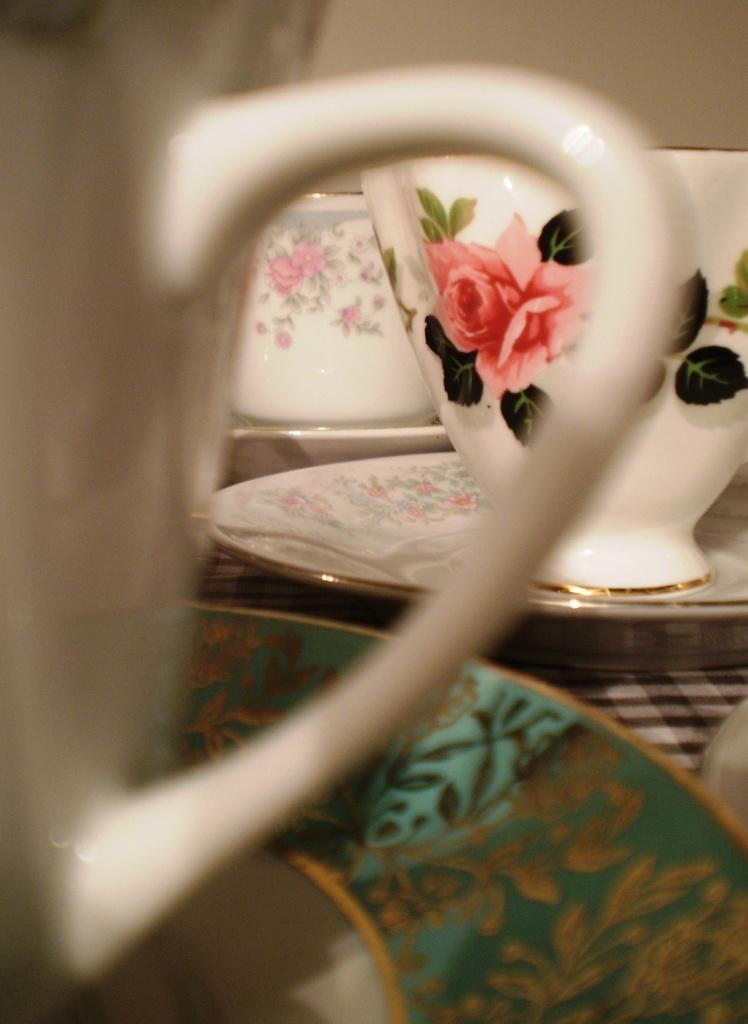What type of dishware can be seen in the image? There are cups and saucers in the image. Are the cups and saucers plain or decorated? The cups and saucers have some painting on them. What is placed beneath the saucers? There is a cloth below the saucers. What type of lettuce is used as a decoration on the cups and saucers in the image? There is no lettuce present on the cups and saucers in the image; they are decorated with some painting. 